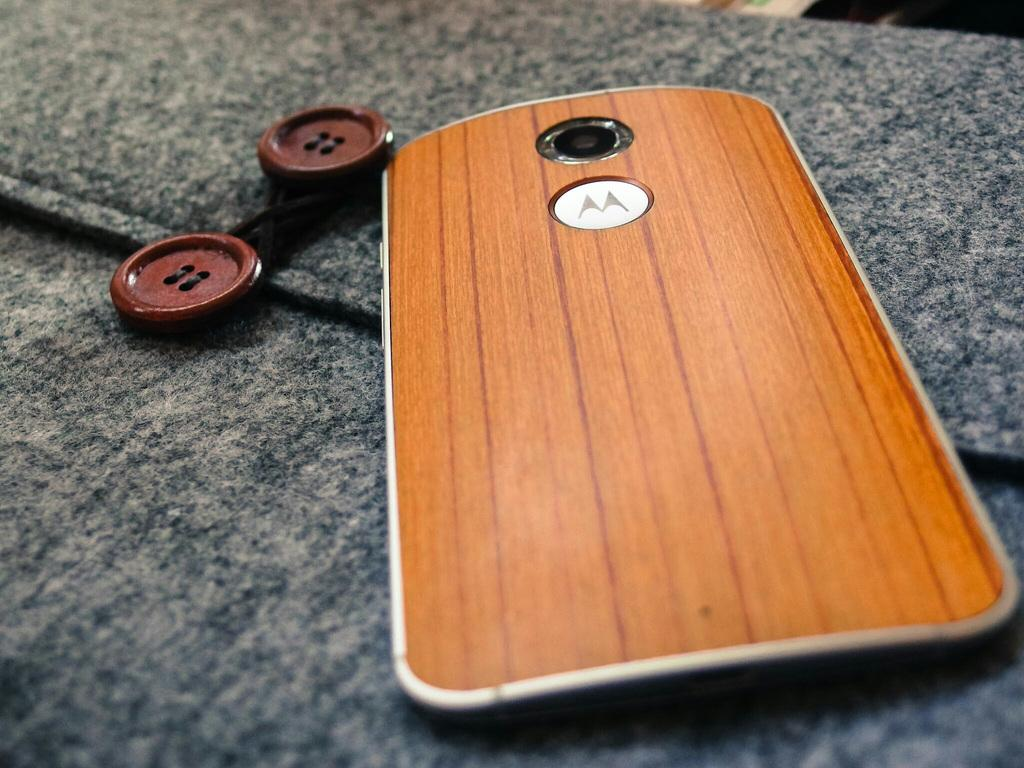<image>
Render a clear and concise summary of the photo. A Motorola mobile phone had a wood effect cover and rests on a woolen suit by its buttons. 